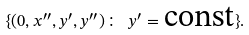Convert formula to latex. <formula><loc_0><loc_0><loc_500><loc_500>\{ ( 0 , x ^ { \prime \prime } , y ^ { \prime } , y ^ { \prime \prime } ) \colon \ y ^ { \prime } = \text {const} \} .</formula> 